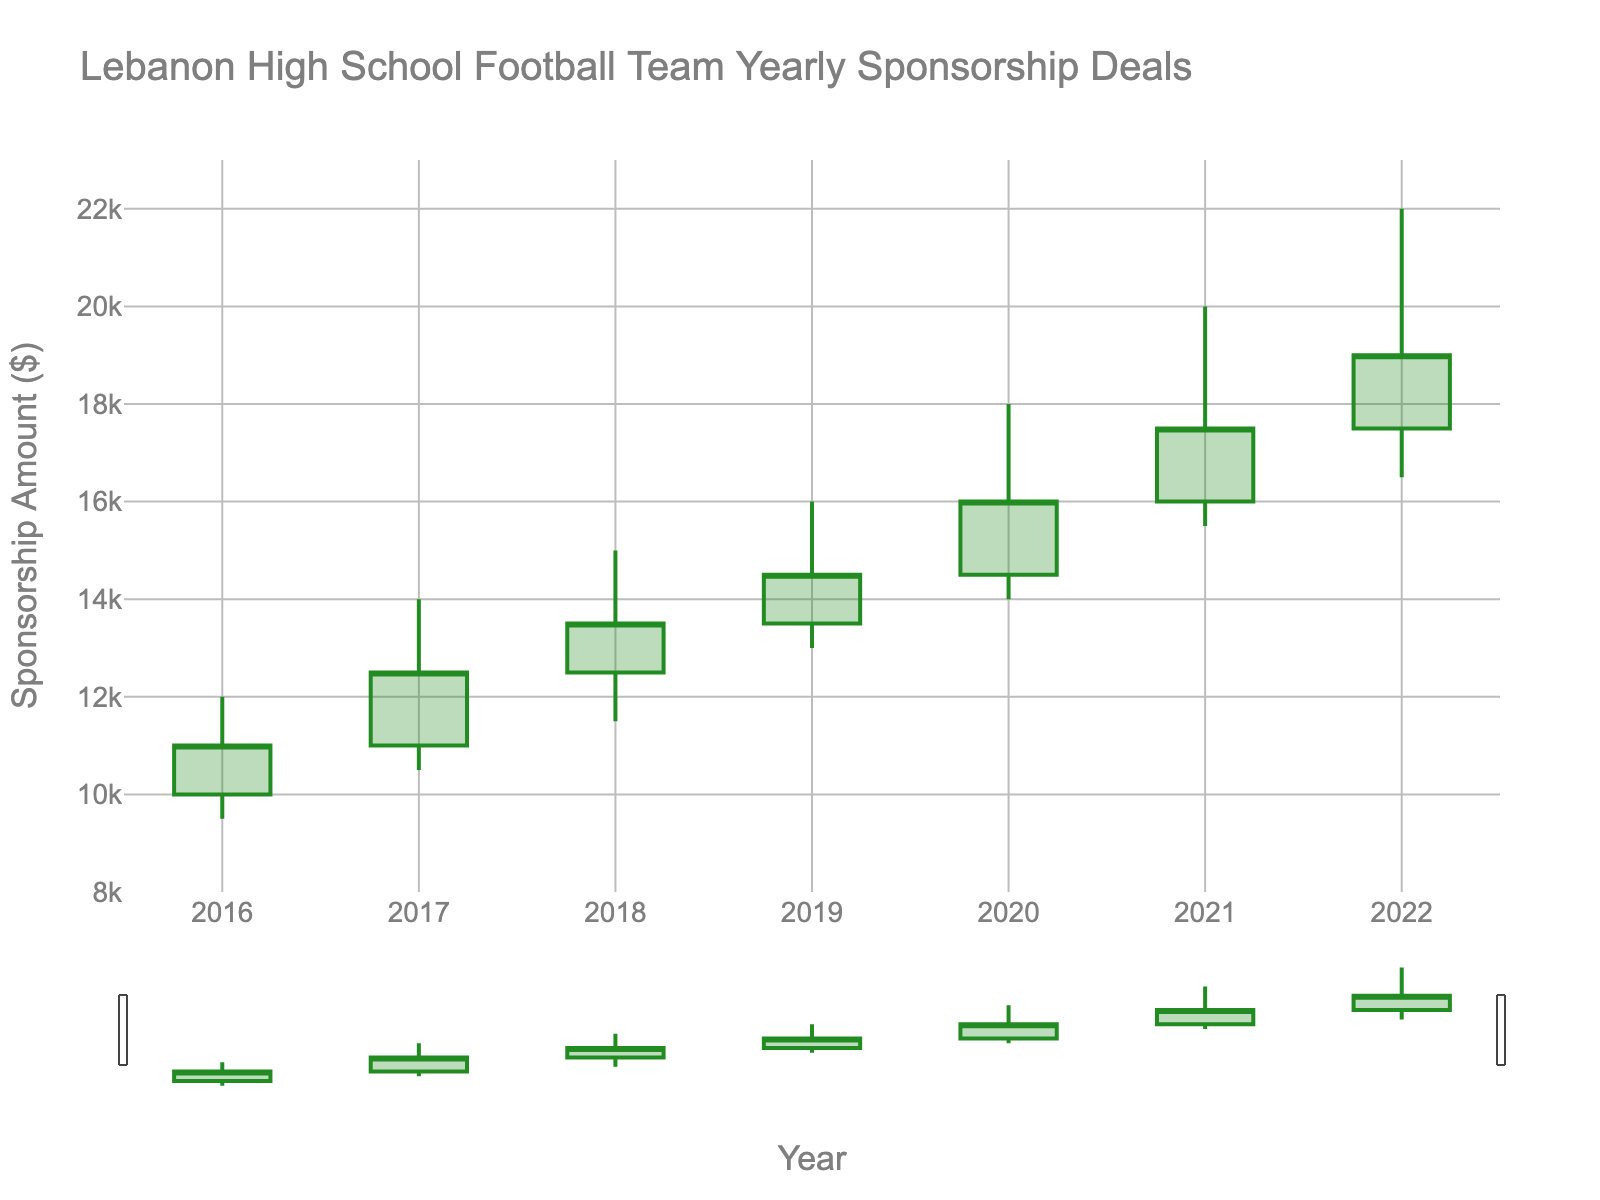What's the title of the plot? Look at the top of the figure, where the title is displayed. It provides a quick summary of the data presented.
Answer: Lebanon High School Football Team Yearly Sponsorship Deals What are the years covered in this plot? Observe the x-axis of the plot. It spans from the left-most point to the right-most point, showing the years.
Answer: 2016 to 2022 In which year did the team secure the highest sponsorship deal amount? Check the highest point on the plot, which indicates the peak High value. Trace it back to the corresponding year on the x-axis.
Answer: 2022 What is the range of sponsorship amounts in 2021? Refer to the candlestick for 2021, noting both the highest and lowest points on the figure.
Answer: 15500 to 20000 How much did the sponsorship amount increase from the opening to the closing in 2019? Look at the Open and Close prices for 2019, then subtract the Open price from the Close price to get the increase.
Answer: 1000 In which year did the sponsorship amount see the least difference between the high and low values? Calculate the difference between the High and Low values for each year and identify the smallest difference.
Answer: 2016 Which year had the steepest rise in the return from the low value to the closing value? For each year, subtract the Low value from the Close value and find the year with the highest result.
Answer: 2020 Did the sponsorship amount ever decrease from opening to closing? If so, in which year? Compare the Open and Close prices for each year. If the Open is greater than the Close, then it indicates a decrease.
Answer: No What was the general trend of the sponsorship deals from 2016 to 2022? Observe the trendlines formed by the candlestick plot over the years from the left to the right.
Answer: Increasing How did the sponsorship amount in 2020 compare to 2016? Compare both the open and close prices of 2020 with those of 2016.
Answer: Higher in 2020 